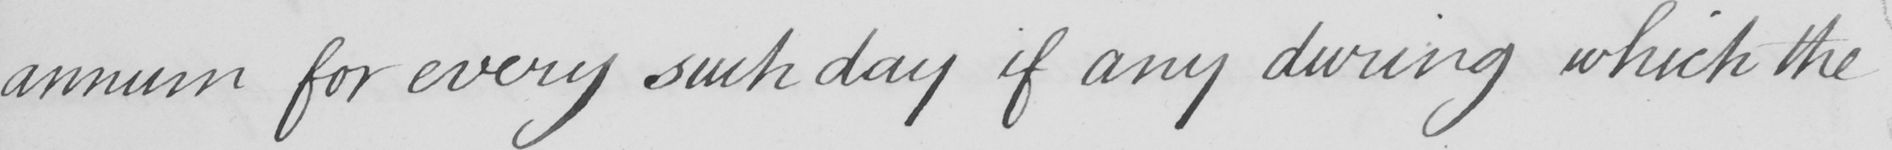What does this handwritten line say? annum for every such day if any during which the 